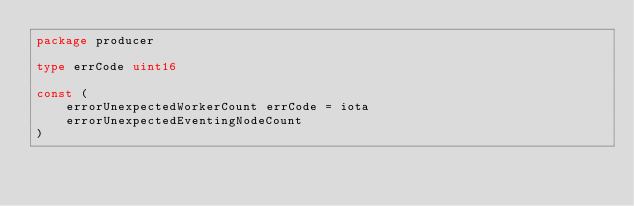<code> <loc_0><loc_0><loc_500><loc_500><_Go_>package producer

type errCode uint16

const (
	errorUnexpectedWorkerCount errCode = iota
	errorUnexpectedEventingNodeCount
)
</code> 